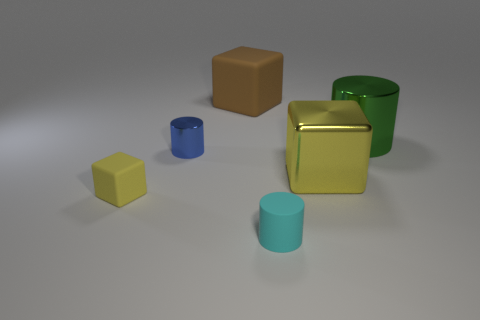What shape is the rubber object that is both on the right side of the tiny blue metallic object and in front of the tiny blue cylinder?
Give a very brief answer. Cylinder. What is the shape of the shiny thing that is on the left side of the big brown block that is right of the block that is on the left side of the brown rubber object?
Give a very brief answer. Cylinder. How many objects are either green things or small matte objects that are right of the tiny yellow thing?
Offer a very short reply. 2. Is the shape of the matte object that is to the left of the big brown thing the same as the tiny thing that is behind the yellow matte block?
Your response must be concise. No. What number of things are either large shiny objects or red matte cylinders?
Make the answer very short. 2. Is there any other thing that has the same material as the large green cylinder?
Give a very brief answer. Yes. Is there a small sphere?
Offer a very short reply. No. Does the yellow thing that is right of the small cube have the same material as the cyan object?
Keep it short and to the point. No. Is there a green metal thing that has the same shape as the tiny cyan rubber object?
Offer a very short reply. Yes. Are there an equal number of big brown objects behind the brown cube and tiny brown shiny objects?
Make the answer very short. Yes. 